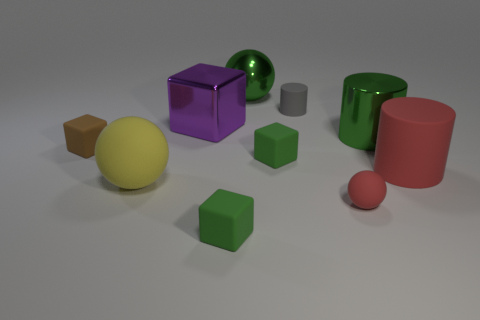There is a gray object that is made of the same material as the brown block; what is its shape?
Your answer should be compact. Cylinder. Is there any other thing that is the same shape as the big purple shiny object?
Your response must be concise. Yes. The big purple metal thing has what shape?
Offer a terse response. Cube. There is a red object behind the tiny sphere; does it have the same shape as the small gray matte thing?
Keep it short and to the point. Yes. Are there more yellow objects that are on the right side of the tiny gray matte thing than brown rubber blocks that are behind the shiny block?
Ensure brevity in your answer.  No. What number of other things are the same size as the gray rubber cylinder?
Your response must be concise. 4. There is a yellow thing; is it the same shape as the big green metal thing that is behind the big purple block?
Keep it short and to the point. Yes. How many rubber objects are large purple cylinders or yellow things?
Your answer should be compact. 1. Is there a small object of the same color as the tiny rubber cylinder?
Your answer should be compact. No. Is there a large yellow matte thing?
Your answer should be compact. Yes. 